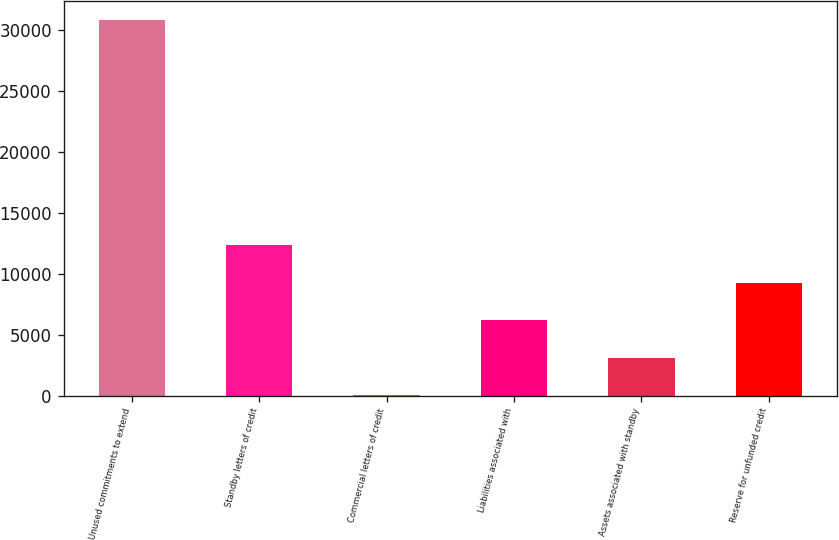Convert chart to OTSL. <chart><loc_0><loc_0><loc_500><loc_500><bar_chart><fcel>Unused commitments to extend<fcel>Standby letters of credit<fcel>Commercial letters of credit<fcel>Liabilities associated with<fcel>Assets associated with standby<fcel>Reserve for unfunded credit<nl><fcel>30828<fcel>12360.6<fcel>49<fcel>6204.8<fcel>3126.9<fcel>9282.7<nl></chart> 